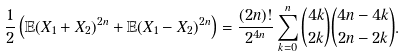<formula> <loc_0><loc_0><loc_500><loc_500>\frac { 1 } { 2 } \left ( \mathbb { E } ( X _ { 1 } + X _ { 2 } ) ^ { 2 n } + \mathbb { E } ( X _ { 1 } - X _ { 2 } ) ^ { 2 n } \right ) = \frac { ( 2 n ) ! } { 2 ^ { 4 n } } \sum _ { k = 0 } ^ { n } \binom { 4 k } { 2 k } \binom { 4 n - 4 k } { 2 n - 2 k } .</formula> 